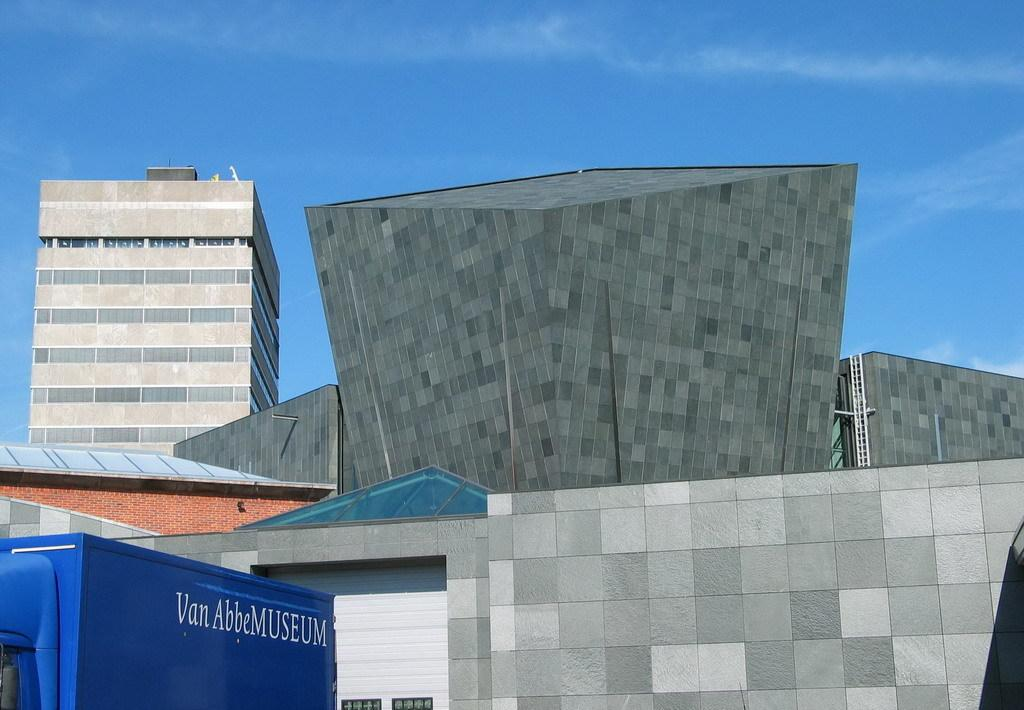What type of structures can be seen in the image? There are buildings in the image. What material is used for the rods in the image? The rods in the image are made of metal. What type of light can be seen emanating from the clock in the image? There is no clock present in the image, so it is not possible to determine what type of light might be emanating from it. 